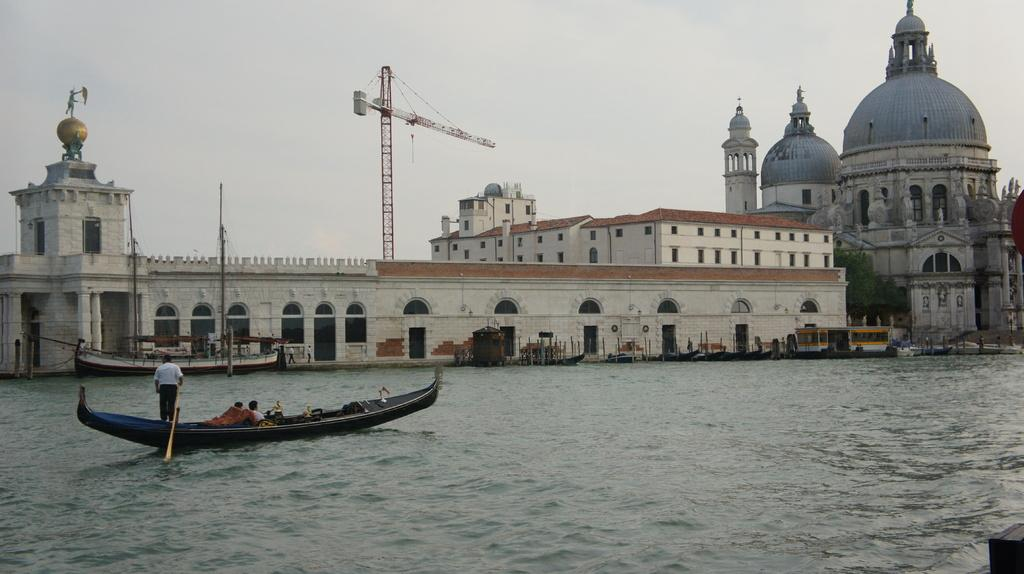What is the primary element in the image? There is water in the image. What types of vehicles are present in the image? There are boats in the image. Who or what is present in the image besides the boats? There are people, buildings, and a tree in the image. What part of the natural environment is visible in the image? The sky is visible in the image. What type of construction equipment can be seen in the distance? There is a tower crane in the distance. What type of plastic is being used to create the wax sculptures in the image? There are no wax sculptures or plastic materials present in the image. 